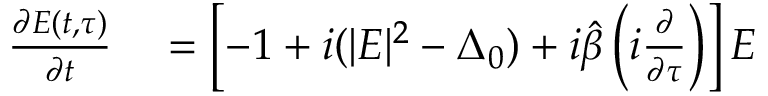Convert formula to latex. <formula><loc_0><loc_0><loc_500><loc_500>\begin{array} { r l } { \frac { \partial E ( t , \tau ) } { \partial t } } & = \left [ - 1 + i ( | E | ^ { 2 } - \Delta _ { 0 } ) + i \hat { \beta } \left ( i \frac { \partial } { \partial \tau } \right ) \right ] E } \end{array}</formula> 